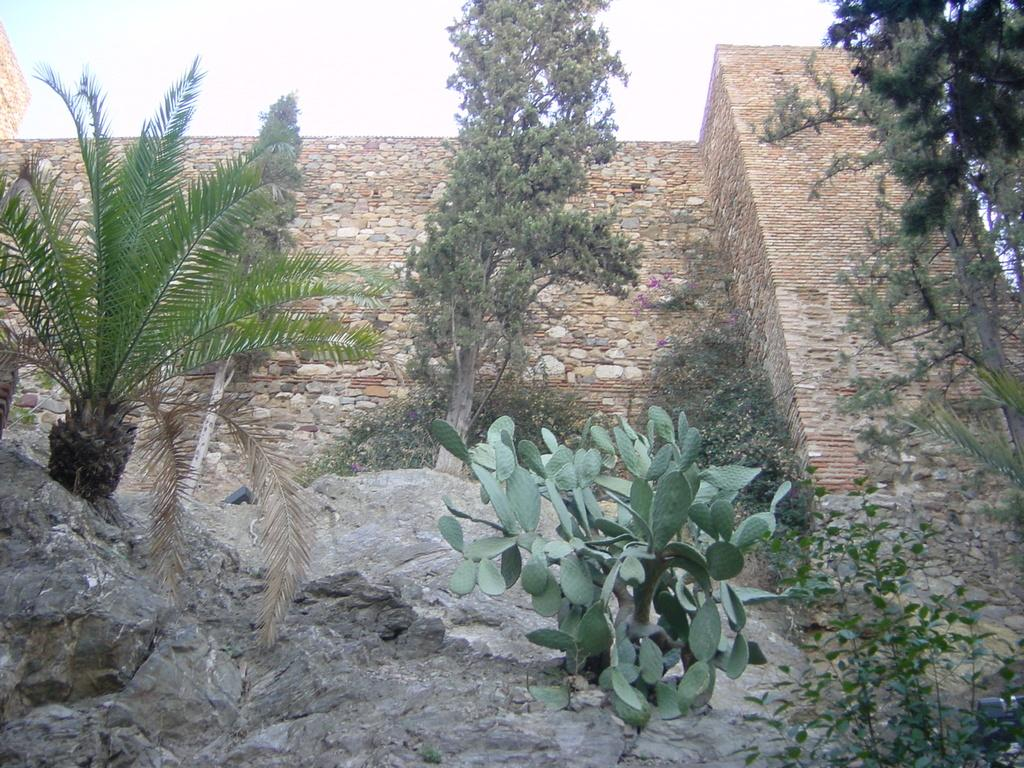What can be found at the bottom of the image? There are rocks and plants at the bottom of the image. What is located at the top of the image? There is a wall and trees at the top of the image. What part of the natural environment is visible in the image? The sky is visible at the top of the image. What does the aunt say about the end of the image? There is no mention of an aunt or an end in the image, as the facts provided only describe the rocks, plants, wall, trees, and sky. 